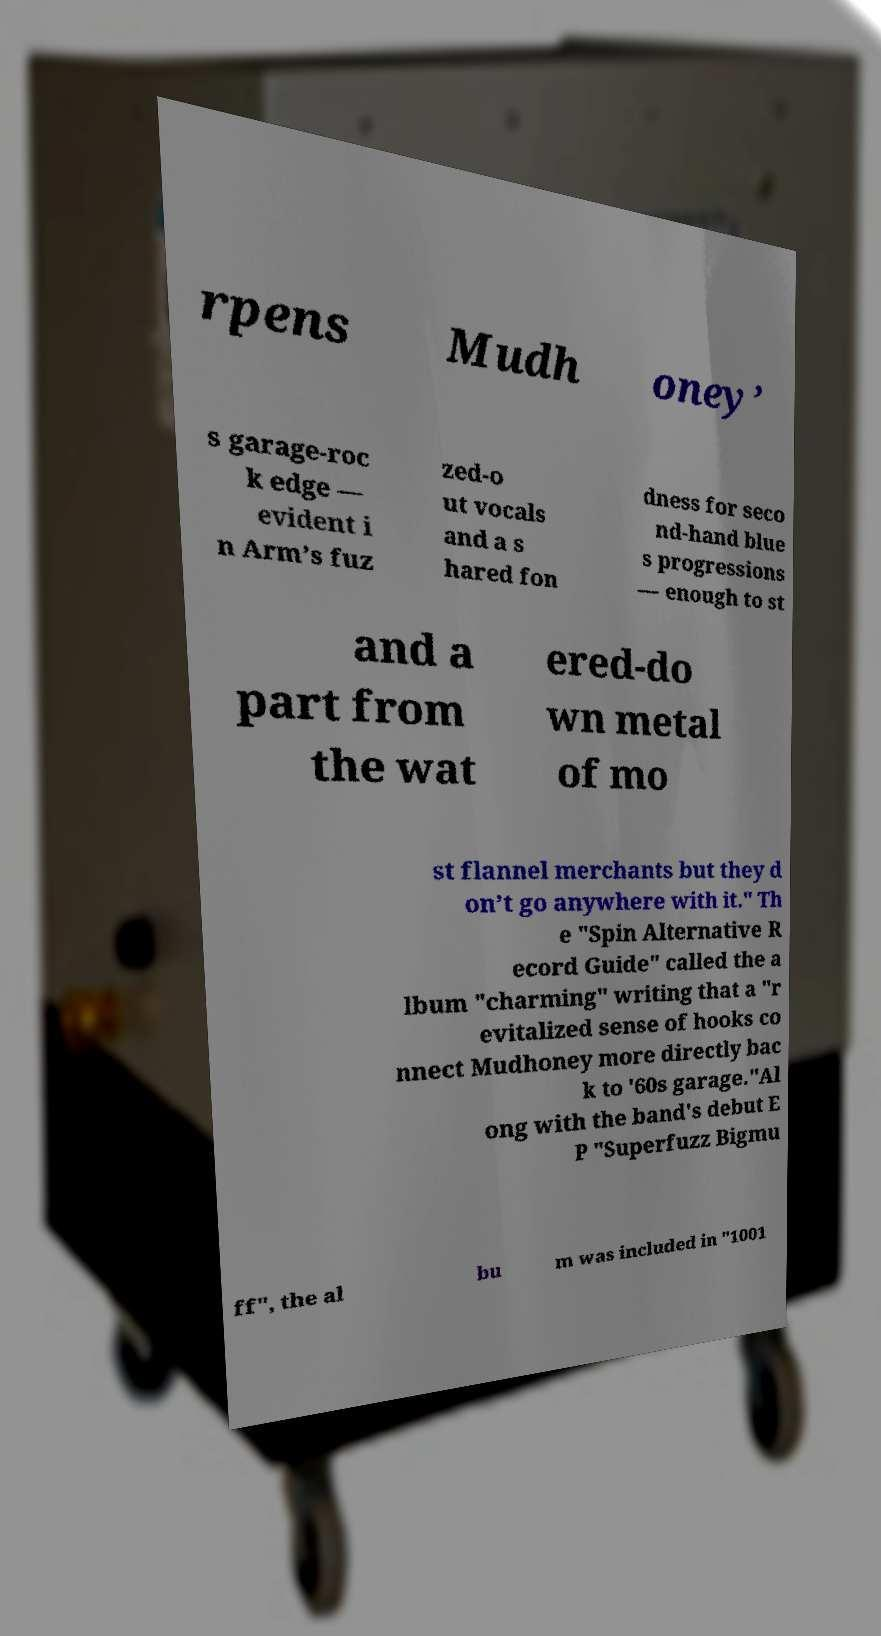Please read and relay the text visible in this image. What does it say? rpens Mudh oney’ s garage-roc k edge — evident i n Arm’s fuz zed-o ut vocals and a s hared fon dness for seco nd-hand blue s progressions — enough to st and a part from the wat ered-do wn metal of mo st flannel merchants but they d on’t go anywhere with it." Th e "Spin Alternative R ecord Guide" called the a lbum "charming" writing that a "r evitalized sense of hooks co nnect Mudhoney more directly bac k to '60s garage."Al ong with the band's debut E P "Superfuzz Bigmu ff", the al bu m was included in "1001 